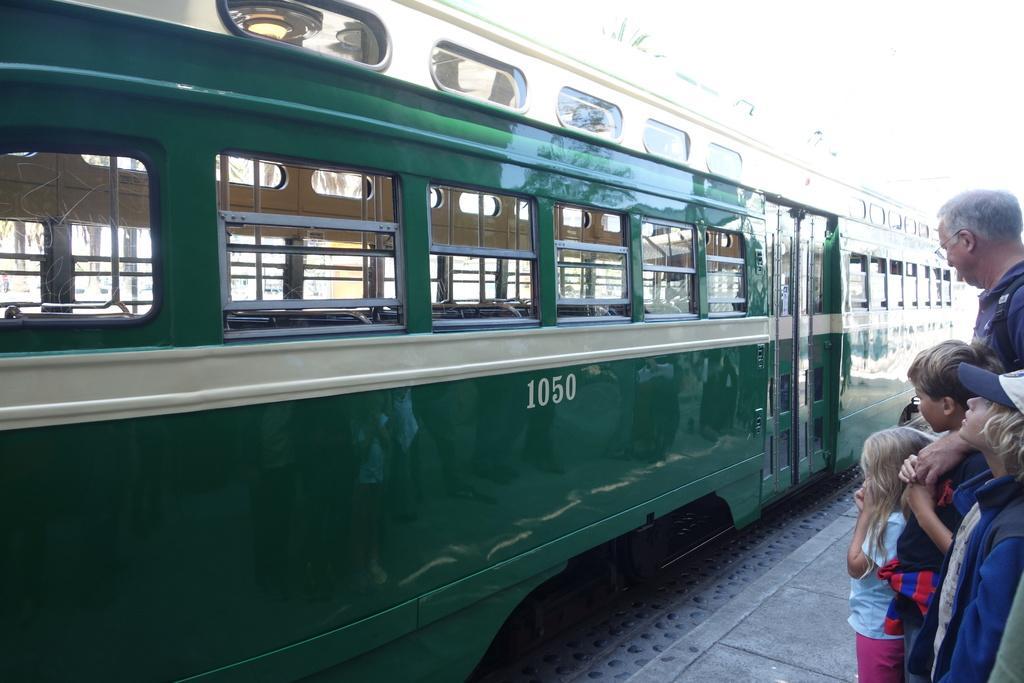How would you summarize this image in a sentence or two? In this image there are three kids and an adult standing on the platform in front of a train. 